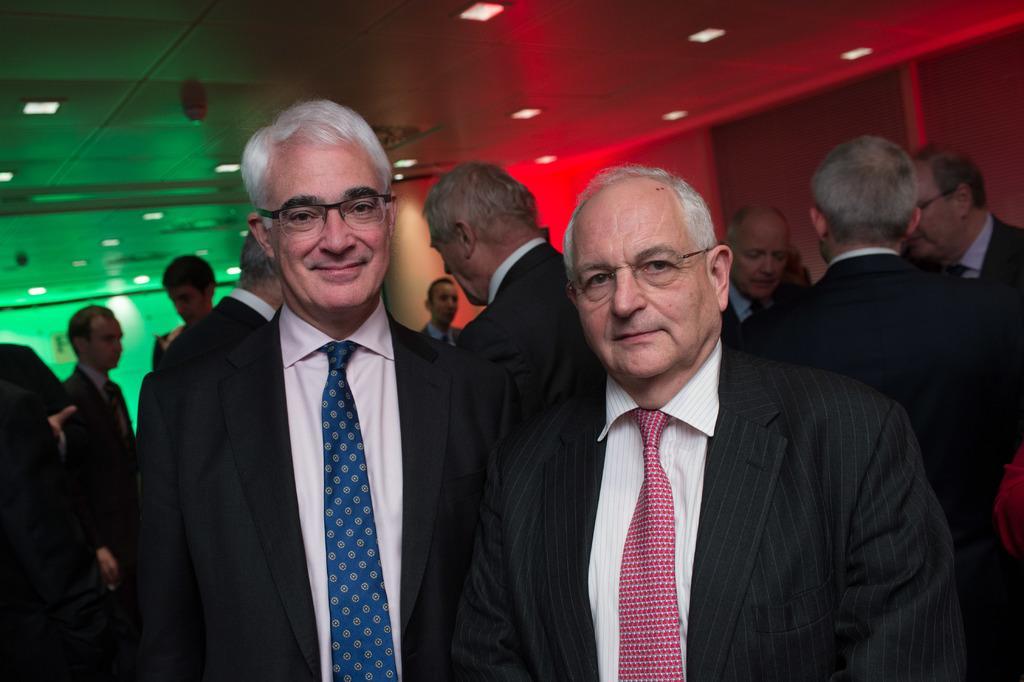Describe this image in one or two sentences. There are two people standing wearing black suit, tie and specs. In the back there are many people. On the ceiling there are lights. On the right side ceiling is red color and on the left side ceiling is green color. 